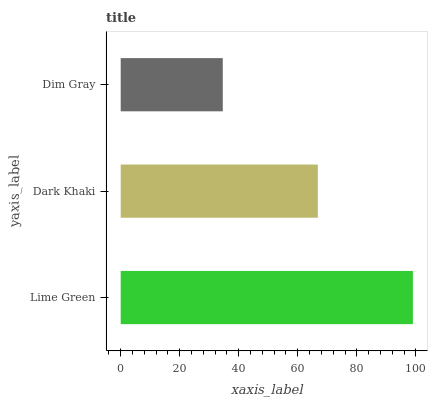Is Dim Gray the minimum?
Answer yes or no. Yes. Is Lime Green the maximum?
Answer yes or no. Yes. Is Dark Khaki the minimum?
Answer yes or no. No. Is Dark Khaki the maximum?
Answer yes or no. No. Is Lime Green greater than Dark Khaki?
Answer yes or no. Yes. Is Dark Khaki less than Lime Green?
Answer yes or no. Yes. Is Dark Khaki greater than Lime Green?
Answer yes or no. No. Is Lime Green less than Dark Khaki?
Answer yes or no. No. Is Dark Khaki the high median?
Answer yes or no. Yes. Is Dark Khaki the low median?
Answer yes or no. Yes. Is Dim Gray the high median?
Answer yes or no. No. Is Dim Gray the low median?
Answer yes or no. No. 